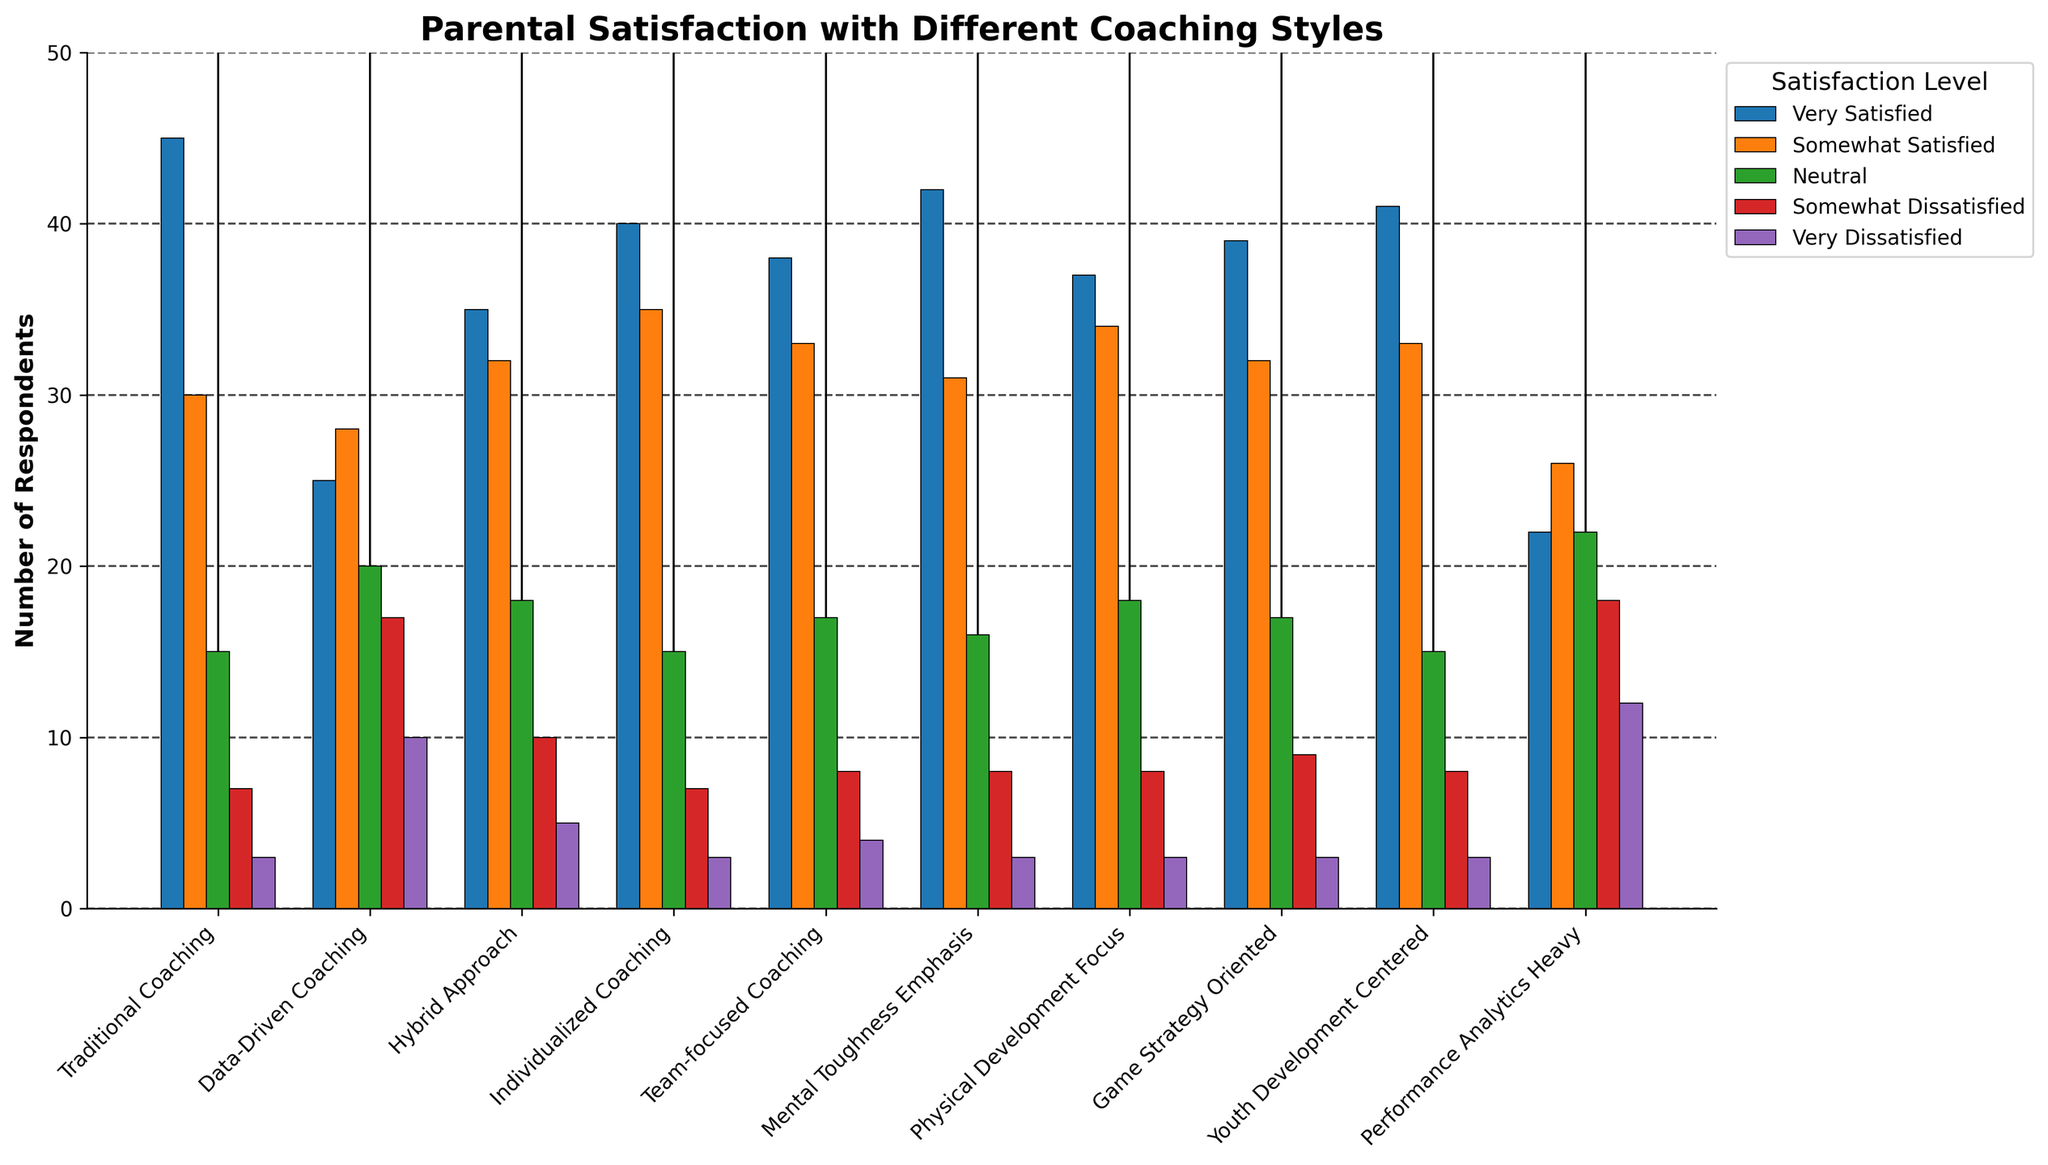Which coaching style has the highest number of parents who are 'Very Satisfied'? Compare the height of the bars labeled 'Very Satisfied' for each coaching style. The tallest bar represents the coaching style with the highest satisfaction.
Answer: Traditional Coaching Which coaching style has the most 'Somewhat Dissatisfied' parents? Compare the height of the bars labeled 'Somewhat Dissatisfied' for each coaching style. The highest bar represents the coaching style with the most somewhat dissatisfied parents.
Answer: Data-Driven Coaching How many more parents are 'Neutral' about the Hybrid Approach compared to Performance Analytics Heavy? Calculate the difference between the 'Neutral' responses for Hybrid Approach and Performance Analytics Heavy by subtracting the latter's count from the former's count.
Answer: -4 What's the combined total number of 'Very Satisfied' and 'Somewhat Satisfied' parents for Individualized Coaching? Add the numbers of 'Very Satisfied' and 'Somewhat Satisfied' parents for Individualized Coaching together.
Answer: 75 Which coaching style has the least 'Very Dissatisfied' parents? Identify the shortest bar labeled 'Very Dissatisfied' among all coaching styles.
Answer: Traditional Coaching Are more parents 'Somewhat Satisfied' or 'Neutral' about Physical Development Focus? Compare the heights of the bars labeled 'Somewhat Satisfied' and 'Neutral' for Physical Development Focus.
Answer: Somewhat Satisfied What is the average number of parents who are 'Very Dissatisfied' across all coaching styles? Sum the number of 'Very Dissatisfied' parents for all coaching styles and divide by the count of coaching styles.
Answer: 4.6 Which coaching style shows the highest dissatisfaction (sum of 'Somewhat Dissatisfied' and 'Very Dissatisfied')? Sum the numbers of 'Somewhat Dissatisfied' and 'Very Dissatisfied' for each coaching style. Identify the highest total.
Answer: Performance Analytics Heavy What is the total number of 'Somewhat Satisfied' parents across all coaching styles? Sum the number of 'Somewhat Satisfied' parents for each coaching style.
Answer: 311 Which coaching style has an equal number of 'Very Dissatisfied' and 'Somewhat Dissatisfied' parents? Compare the numbers of 'Very Dissatisfied' and 'Somewhat Dissatisfied' parents for each coaching style to find the equal values.
Answer: None 